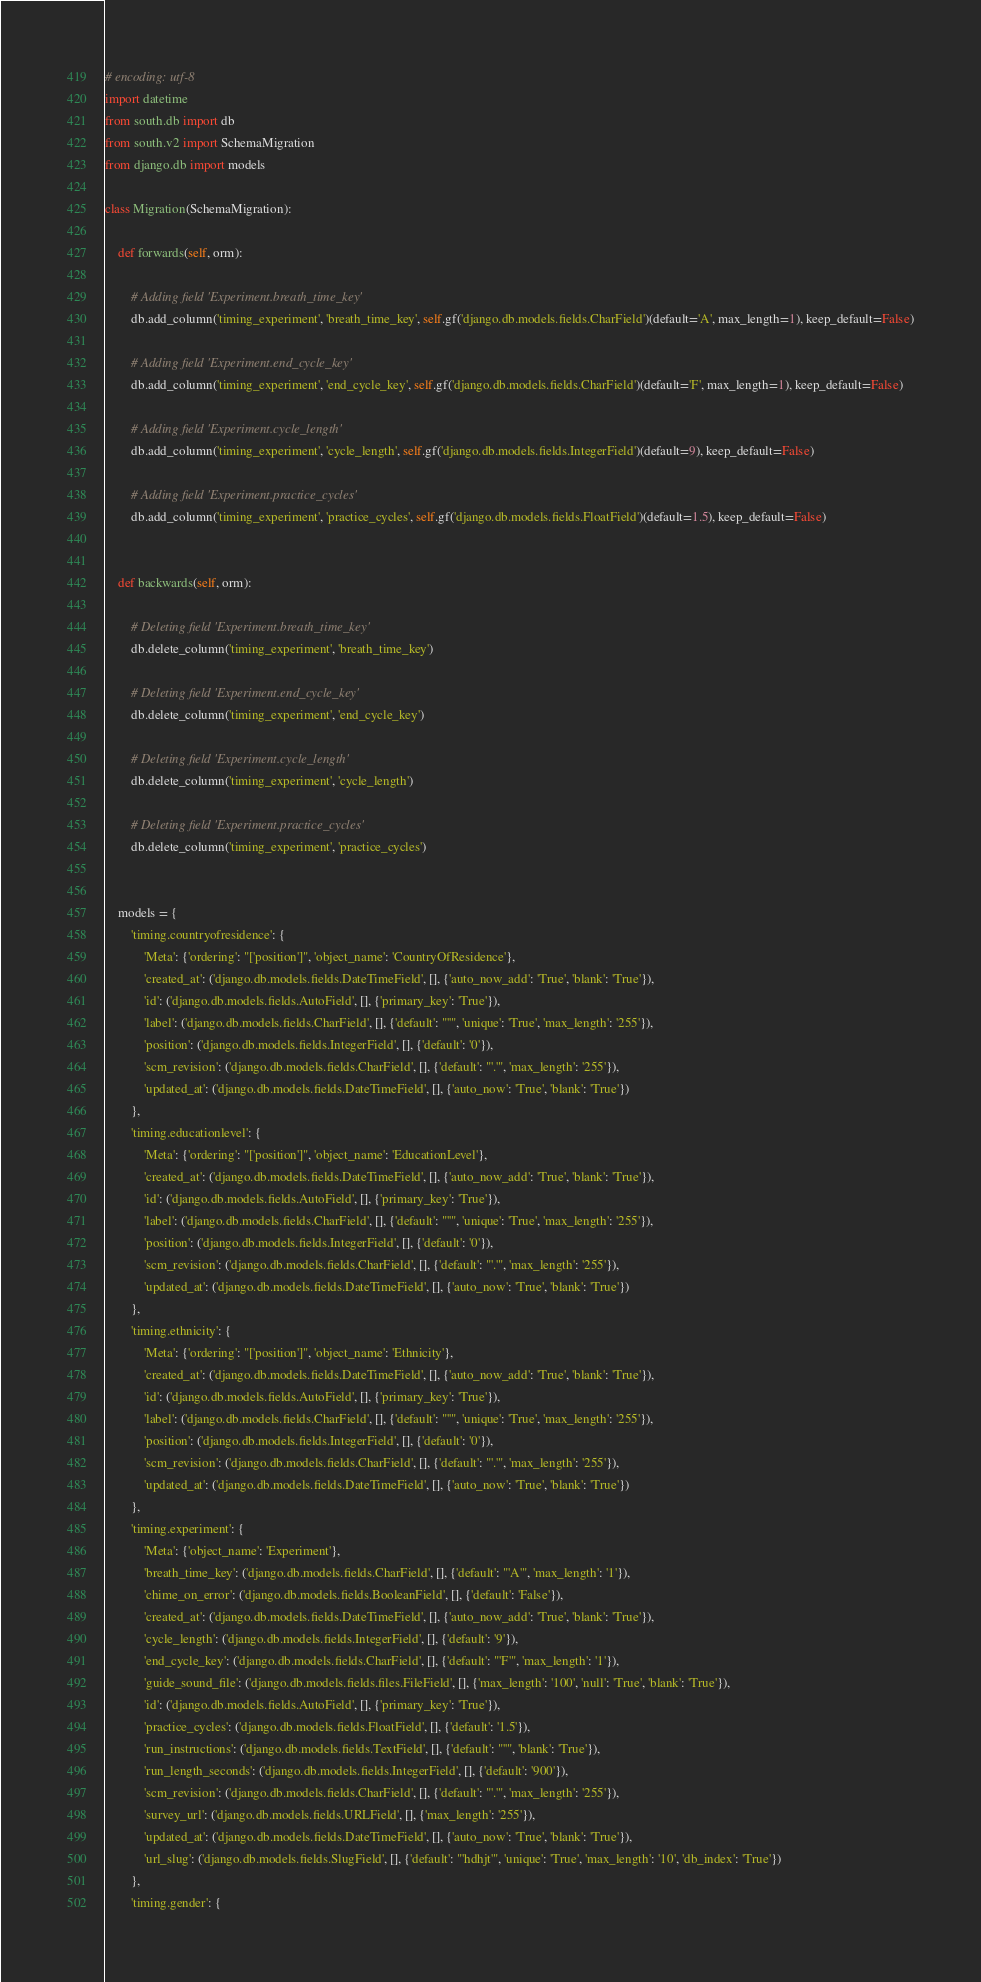<code> <loc_0><loc_0><loc_500><loc_500><_Python_># encoding: utf-8
import datetime
from south.db import db
from south.v2 import SchemaMigration
from django.db import models

class Migration(SchemaMigration):

    def forwards(self, orm):
        
        # Adding field 'Experiment.breath_time_key'
        db.add_column('timing_experiment', 'breath_time_key', self.gf('django.db.models.fields.CharField')(default='A', max_length=1), keep_default=False)

        # Adding field 'Experiment.end_cycle_key'
        db.add_column('timing_experiment', 'end_cycle_key', self.gf('django.db.models.fields.CharField')(default='F', max_length=1), keep_default=False)

        # Adding field 'Experiment.cycle_length'
        db.add_column('timing_experiment', 'cycle_length', self.gf('django.db.models.fields.IntegerField')(default=9), keep_default=False)

        # Adding field 'Experiment.practice_cycles'
        db.add_column('timing_experiment', 'practice_cycles', self.gf('django.db.models.fields.FloatField')(default=1.5), keep_default=False)


    def backwards(self, orm):
        
        # Deleting field 'Experiment.breath_time_key'
        db.delete_column('timing_experiment', 'breath_time_key')

        # Deleting field 'Experiment.end_cycle_key'
        db.delete_column('timing_experiment', 'end_cycle_key')

        # Deleting field 'Experiment.cycle_length'
        db.delete_column('timing_experiment', 'cycle_length')

        # Deleting field 'Experiment.practice_cycles'
        db.delete_column('timing_experiment', 'practice_cycles')


    models = {
        'timing.countryofresidence': {
            'Meta': {'ordering': "['position']", 'object_name': 'CountryOfResidence'},
            'created_at': ('django.db.models.fields.DateTimeField', [], {'auto_now_add': 'True', 'blank': 'True'}),
            'id': ('django.db.models.fields.AutoField', [], {'primary_key': 'True'}),
            'label': ('django.db.models.fields.CharField', [], {'default': "''", 'unique': 'True', 'max_length': '255'}),
            'position': ('django.db.models.fields.IntegerField', [], {'default': '0'}),
            'scm_revision': ('django.db.models.fields.CharField', [], {'default': "'.'", 'max_length': '255'}),
            'updated_at': ('django.db.models.fields.DateTimeField', [], {'auto_now': 'True', 'blank': 'True'})
        },
        'timing.educationlevel': {
            'Meta': {'ordering': "['position']", 'object_name': 'EducationLevel'},
            'created_at': ('django.db.models.fields.DateTimeField', [], {'auto_now_add': 'True', 'blank': 'True'}),
            'id': ('django.db.models.fields.AutoField', [], {'primary_key': 'True'}),
            'label': ('django.db.models.fields.CharField', [], {'default': "''", 'unique': 'True', 'max_length': '255'}),
            'position': ('django.db.models.fields.IntegerField', [], {'default': '0'}),
            'scm_revision': ('django.db.models.fields.CharField', [], {'default': "'.'", 'max_length': '255'}),
            'updated_at': ('django.db.models.fields.DateTimeField', [], {'auto_now': 'True', 'blank': 'True'})
        },
        'timing.ethnicity': {
            'Meta': {'ordering': "['position']", 'object_name': 'Ethnicity'},
            'created_at': ('django.db.models.fields.DateTimeField', [], {'auto_now_add': 'True', 'blank': 'True'}),
            'id': ('django.db.models.fields.AutoField', [], {'primary_key': 'True'}),
            'label': ('django.db.models.fields.CharField', [], {'default': "''", 'unique': 'True', 'max_length': '255'}),
            'position': ('django.db.models.fields.IntegerField', [], {'default': '0'}),
            'scm_revision': ('django.db.models.fields.CharField', [], {'default': "'.'", 'max_length': '255'}),
            'updated_at': ('django.db.models.fields.DateTimeField', [], {'auto_now': 'True', 'blank': 'True'})
        },
        'timing.experiment': {
            'Meta': {'object_name': 'Experiment'},
            'breath_time_key': ('django.db.models.fields.CharField', [], {'default': "'A'", 'max_length': '1'}),
            'chime_on_error': ('django.db.models.fields.BooleanField', [], {'default': 'False'}),
            'created_at': ('django.db.models.fields.DateTimeField', [], {'auto_now_add': 'True', 'blank': 'True'}),
            'cycle_length': ('django.db.models.fields.IntegerField', [], {'default': '9'}),
            'end_cycle_key': ('django.db.models.fields.CharField', [], {'default': "'F'", 'max_length': '1'}),
            'guide_sound_file': ('django.db.models.fields.files.FileField', [], {'max_length': '100', 'null': 'True', 'blank': 'True'}),
            'id': ('django.db.models.fields.AutoField', [], {'primary_key': 'True'}),
            'practice_cycles': ('django.db.models.fields.FloatField', [], {'default': '1.5'}),
            'run_instructions': ('django.db.models.fields.TextField', [], {'default': "''", 'blank': 'True'}),
            'run_length_seconds': ('django.db.models.fields.IntegerField', [], {'default': '900'}),
            'scm_revision': ('django.db.models.fields.CharField', [], {'default': "'.'", 'max_length': '255'}),
            'survey_url': ('django.db.models.fields.URLField', [], {'max_length': '255'}),
            'updated_at': ('django.db.models.fields.DateTimeField', [], {'auto_now': 'True', 'blank': 'True'}),
            'url_slug': ('django.db.models.fields.SlugField', [], {'default': "'hdhjt'", 'unique': 'True', 'max_length': '10', 'db_index': 'True'})
        },
        'timing.gender': {</code> 